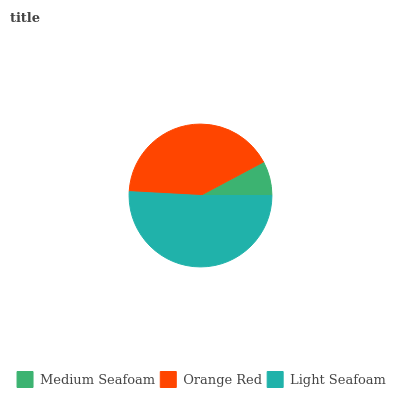Is Medium Seafoam the minimum?
Answer yes or no. Yes. Is Light Seafoam the maximum?
Answer yes or no. Yes. Is Orange Red the minimum?
Answer yes or no. No. Is Orange Red the maximum?
Answer yes or no. No. Is Orange Red greater than Medium Seafoam?
Answer yes or no. Yes. Is Medium Seafoam less than Orange Red?
Answer yes or no. Yes. Is Medium Seafoam greater than Orange Red?
Answer yes or no. No. Is Orange Red less than Medium Seafoam?
Answer yes or no. No. Is Orange Red the high median?
Answer yes or no. Yes. Is Orange Red the low median?
Answer yes or no. Yes. Is Light Seafoam the high median?
Answer yes or no. No. Is Medium Seafoam the low median?
Answer yes or no. No. 